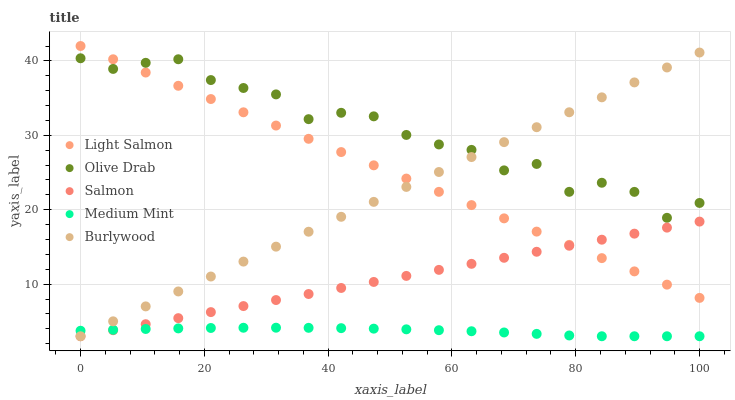Does Medium Mint have the minimum area under the curve?
Answer yes or no. Yes. Does Olive Drab have the maximum area under the curve?
Answer yes or no. Yes. Does Burlywood have the minimum area under the curve?
Answer yes or no. No. Does Burlywood have the maximum area under the curve?
Answer yes or no. No. Is Salmon the smoothest?
Answer yes or no. Yes. Is Olive Drab the roughest?
Answer yes or no. Yes. Is Burlywood the smoothest?
Answer yes or no. No. Is Burlywood the roughest?
Answer yes or no. No. Does Medium Mint have the lowest value?
Answer yes or no. Yes. Does Light Salmon have the lowest value?
Answer yes or no. No. Does Light Salmon have the highest value?
Answer yes or no. Yes. Does Burlywood have the highest value?
Answer yes or no. No. Is Salmon less than Olive Drab?
Answer yes or no. Yes. Is Olive Drab greater than Salmon?
Answer yes or no. Yes. Does Light Salmon intersect Salmon?
Answer yes or no. Yes. Is Light Salmon less than Salmon?
Answer yes or no. No. Is Light Salmon greater than Salmon?
Answer yes or no. No. Does Salmon intersect Olive Drab?
Answer yes or no. No. 